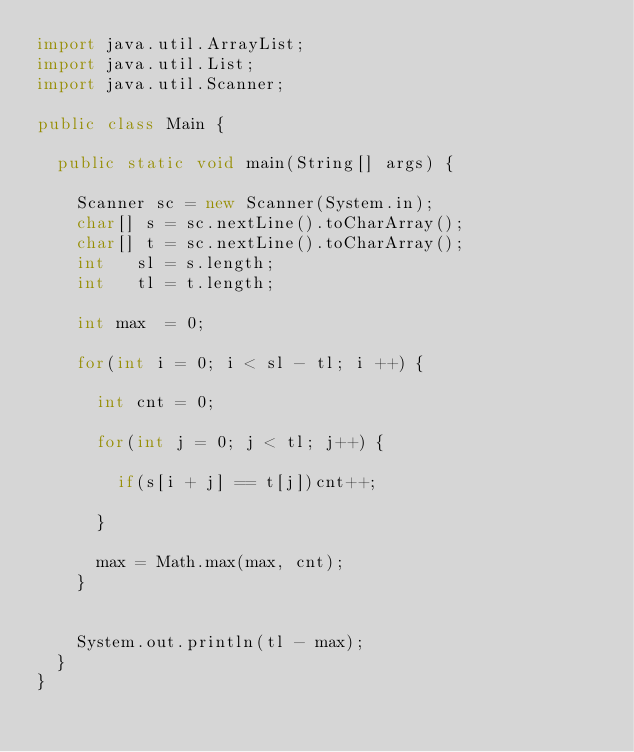Convert code to text. <code><loc_0><loc_0><loc_500><loc_500><_Java_>import java.util.ArrayList;
import java.util.List;
import java.util.Scanner;

public class Main {

	public static void main(String[] args) {

		Scanner sc = new Scanner(System.in);
		char[] s = sc.nextLine().toCharArray();
		char[] t = sc.nextLine().toCharArray();
		int   sl = s.length;
		int   tl = t.length;

		int max  = 0;

		for(int i = 0; i < sl - tl; i ++) {

			int cnt = 0;

			for(int j = 0; j < tl; j++) {

				if(s[i + j] == t[j])cnt++;

			}

			max = Math.max(max, cnt);
		}


		System.out.println(tl - max);
	}
}
</code> 